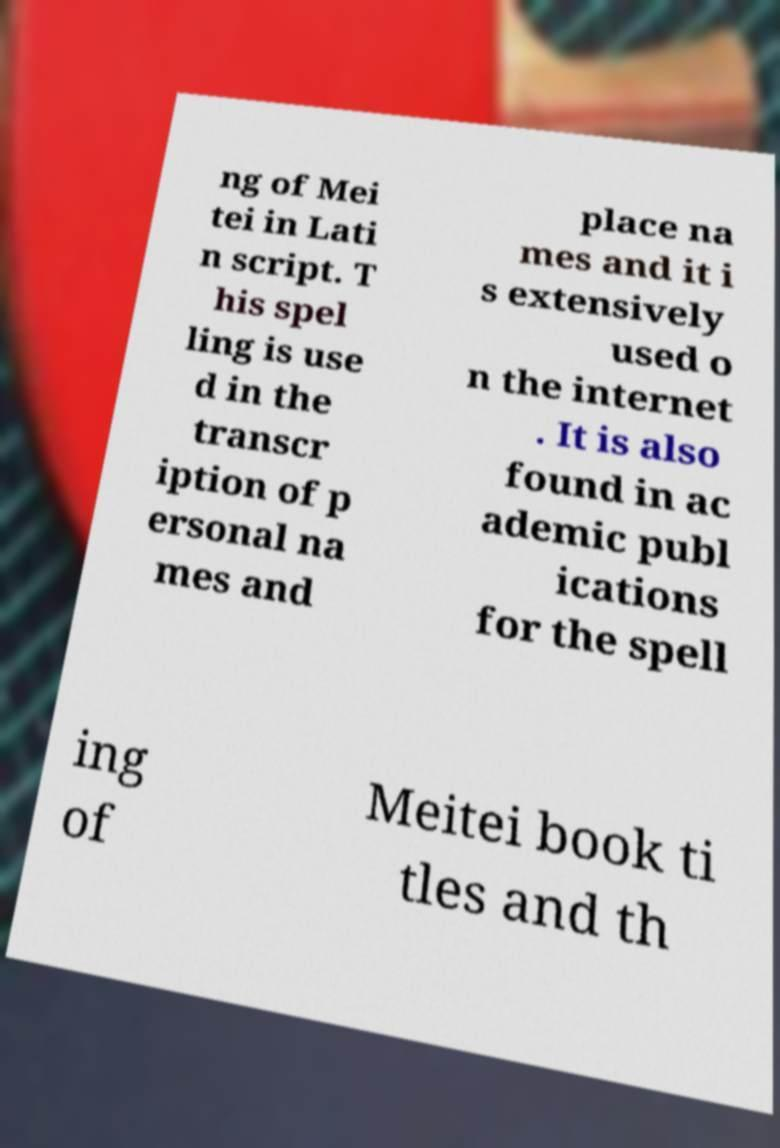Please read and relay the text visible in this image. What does it say? ng of Mei tei in Lati n script. T his spel ling is use d in the transcr iption of p ersonal na mes and place na mes and it i s extensively used o n the internet . It is also found in ac ademic publ ications for the spell ing of Meitei book ti tles and th 